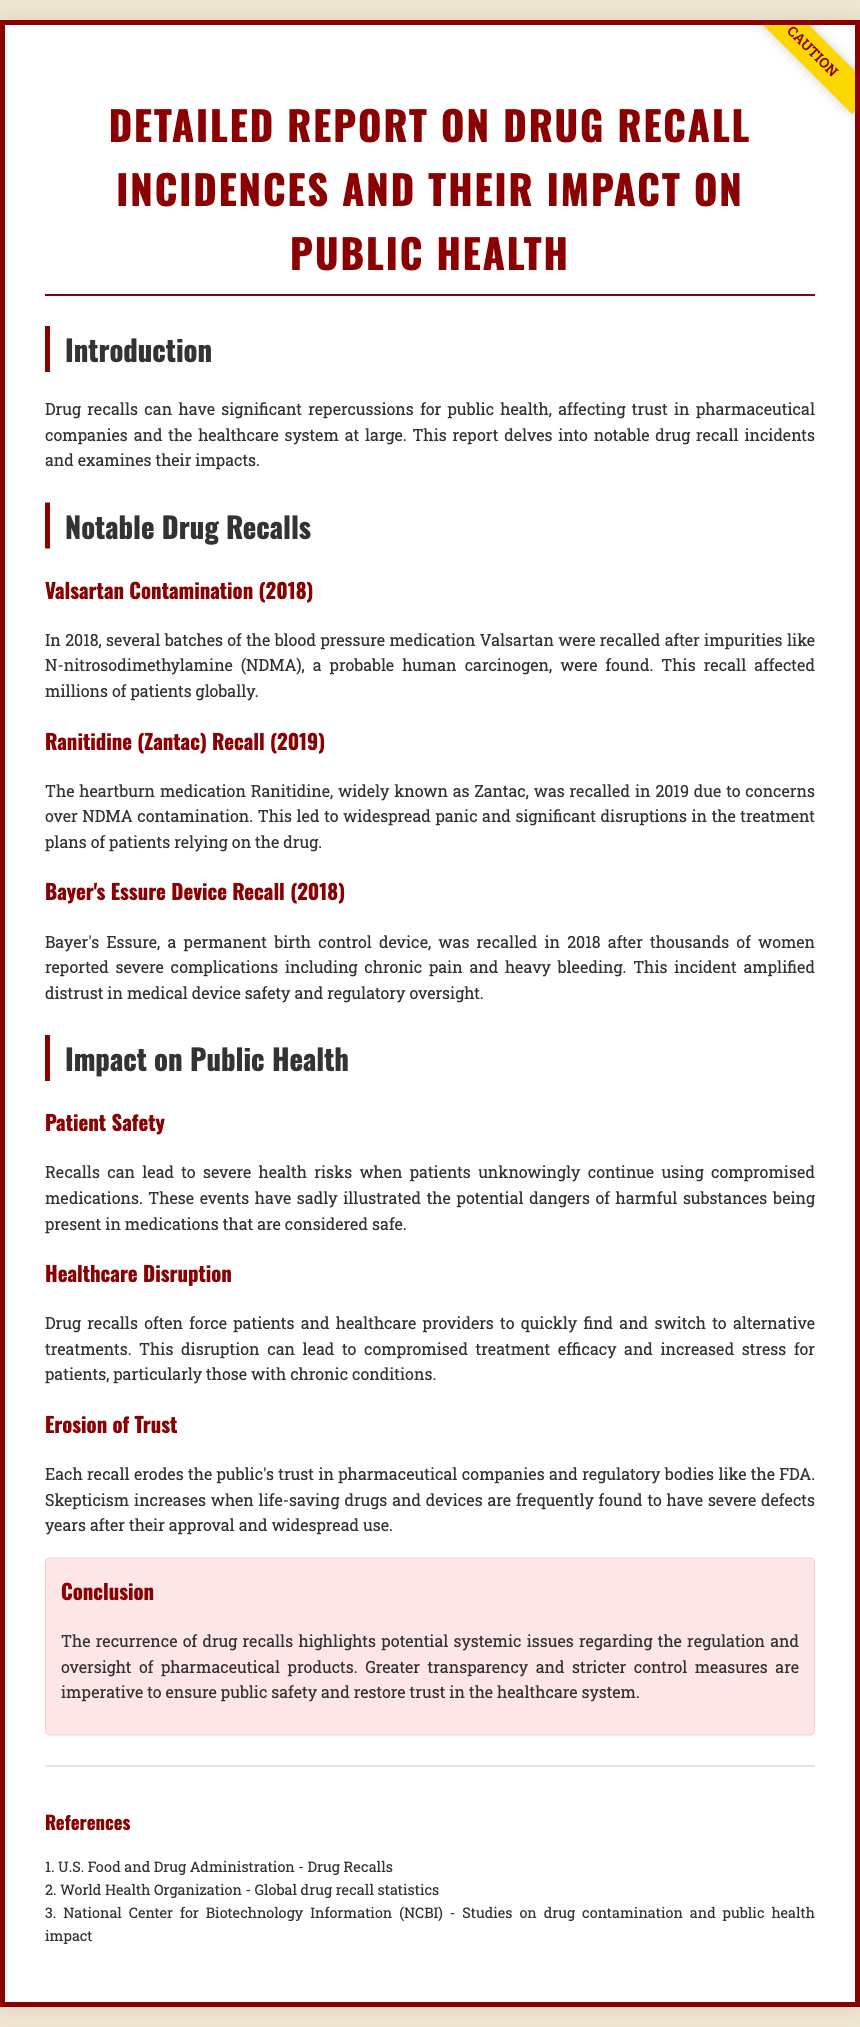What was recalled in 2018? The report mentions the recall of Valsartan in 2018 due to contamination.
Answer: Valsartan What contaminant was found in Ranitidine? The document states that Ranitidine was recalled due to concerns over NDMA contamination.
Answer: NDMA What significant issue did Bayer's Essure device cause? The report highlights that thousands of women reported severe complications including chronic pain and heavy bleeding.
Answer: Severe complications What year did the Ranitidine recall occur? According to the document, the Ranitidine recall happened in 2019.
Answer: 2019 What does the conclusion suggest is imperative to public safety? The conclusion indicates that greater transparency and stricter control measures are imperative.
Answer: Greater transparency and stricter control measures What general impact do drug recalls have on public trust? The report discusses how each recall erodes the public's trust in pharmaceutical companies and regulatory bodies.
Answer: Erodes trust How many notable drug recalls are mentioned? The document details three notable drug recalls.
Answer: Three What is one consequence of drug recalls for patient care? The report mentions that drug recalls can lead to compromised treatment efficacy for patients.
Answer: Compromised treatment efficacy What is the color of the warning box in the document? The warning section is highlighted with a background color of light pink.
Answer: Light pink 